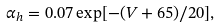<formula> <loc_0><loc_0><loc_500><loc_500>\alpha _ { h } = 0 . 0 7 \exp [ - ( V + 6 5 ) / 2 0 ] ,</formula> 